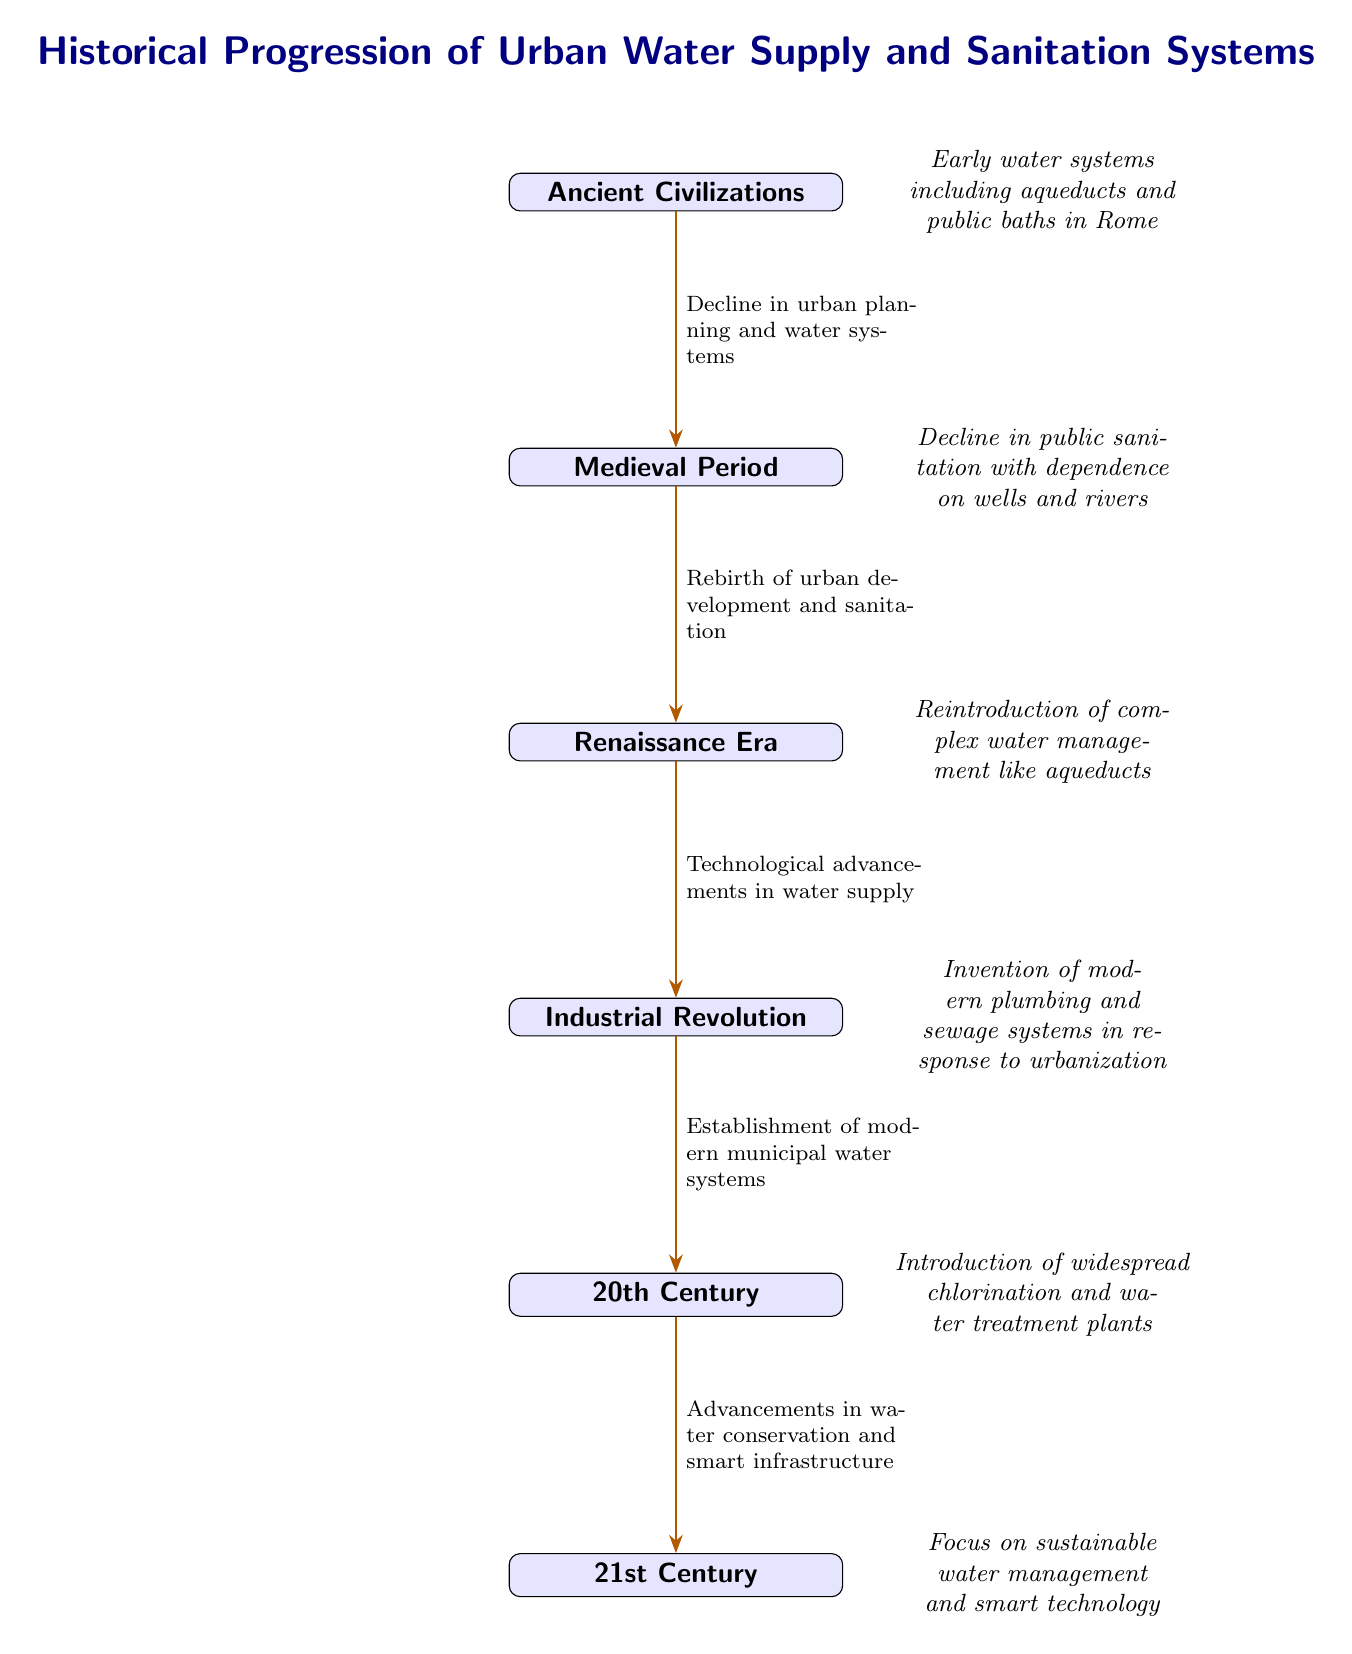What major water system developed in Ancient Civilizations? The diagram indicates that early water systems included aqueducts and public baths in Rome, which are significant advancements in urban water management during that era.
Answer: Aqueducts What transition marks the relationship between the Medieval Period and the Renaissance Era? According to the diagram, the transition indicates a "Rebirth of urban development and sanitation" from the decline in public sanitation seen in the Medieval Period.
Answer: Rebirth of urban development and sanitation How many distinct time periods are displayed in the diagram? By counting the nodes listed vertically, there are six distinct time periods, each representing a different era in the history of urban water supply and sanitation systems.
Answer: Six What significant invention arose during the Industrial Revolution related to water systems? The diagram shows that the invention of modern plumbing and sewage systems occurred in response to the rapid urbanization of the Industrial Revolution, providing better sanitation and water supply.
Answer: Modern plumbing and sewage systems What type of advancements were introduced in the 20th Century? The diagram notes that in the 20th Century, widespread chlorination and water treatment plants were introduced, highlighting a major shift towards public health and sanitation.
Answer: Widespread chlorination and water treatment plants Which transition signifies a focus on technology in the 21st Century? The transition from the 20th Century to the 21st Century specifically highlights advancements in water conservation and smart infrastructure, emphasizing the technological focus of this period.
Answer: Advancements in water conservation and smart infrastructure How did urban planning affect water systems during the transition from Ancient Civilizations to the Medieval Period? The diagram indicates that there was a "Decline in urban planning and water systems," suggesting a regression in the management of water supply and sanitation as societies faced changes during that time.
Answer: Decline in urban planning and water systems What major focus characterizes the 21st Century compared to the prior periods? The focus on sustainable water management and smart technology distinguishes the 21st Century from previous periods, where the emphasis was more on developing foundational structures for water supply and sanitation.
Answer: Sustainable water management and smart technology What were the consequences of urbanization during the Industrial Revolution in terms of water management? The diagram elaborates that the establishment of modern municipal water systems was a direct response to urbanization, reflecting the necessity for improved water infrastructure in growing urban environments.
Answer: Establishment of modern municipal water systems 